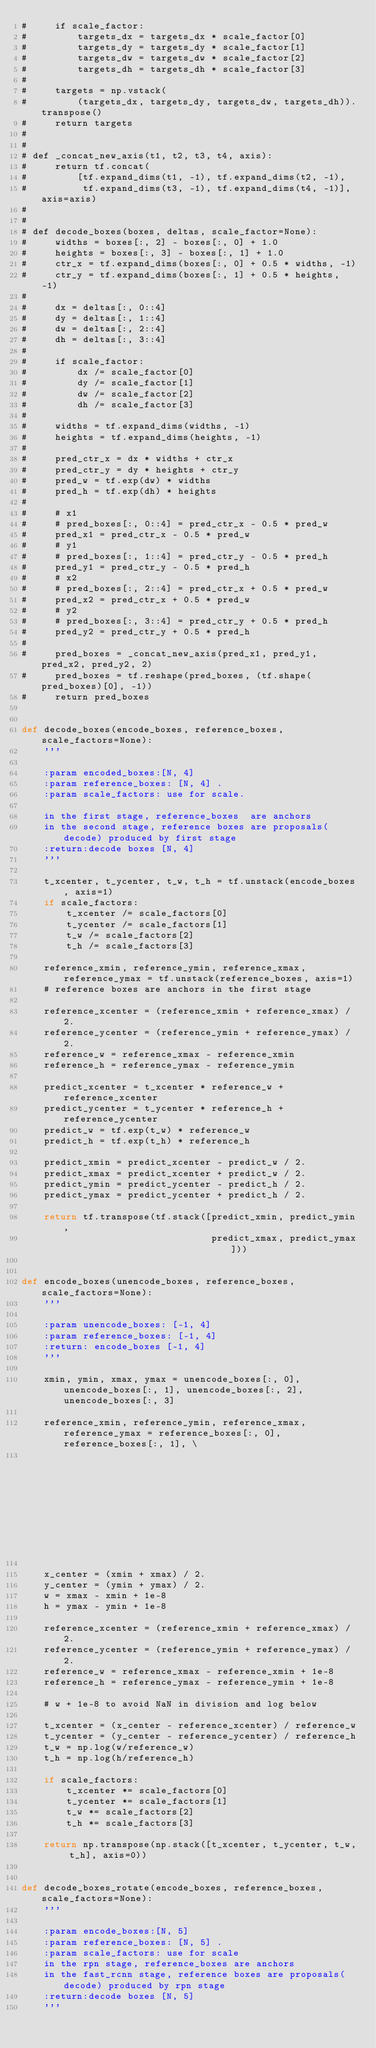Convert code to text. <code><loc_0><loc_0><loc_500><loc_500><_Python_>#     if scale_factor:
#         targets_dx = targets_dx * scale_factor[0]
#         targets_dy = targets_dy * scale_factor[1]
#         targets_dw = targets_dw * scale_factor[2]
#         targets_dh = targets_dh * scale_factor[3]
#
#     targets = np.vstack(
#         (targets_dx, targets_dy, targets_dw, targets_dh)).transpose()
#     return targets
#
#
# def _concat_new_axis(t1, t2, t3, t4, axis):
#     return tf.concat(
#         [tf.expand_dims(t1, -1), tf.expand_dims(t2, -1),
#          tf.expand_dims(t3, -1), tf.expand_dims(t4, -1)], axis=axis)
#
#
# def decode_boxes(boxes, deltas, scale_factor=None):
#     widths = boxes[:, 2] - boxes[:, 0] + 1.0
#     heights = boxes[:, 3] - boxes[:, 1] + 1.0
#     ctr_x = tf.expand_dims(boxes[:, 0] + 0.5 * widths, -1)
#     ctr_y = tf.expand_dims(boxes[:, 1] + 0.5 * heights, -1)
#
#     dx = deltas[:, 0::4]
#     dy = deltas[:, 1::4]
#     dw = deltas[:, 2::4]
#     dh = deltas[:, 3::4]
#
#     if scale_factor:
#         dx /= scale_factor[0]
#         dy /= scale_factor[1]
#         dw /= scale_factor[2]
#         dh /= scale_factor[3]
#
#     widths = tf.expand_dims(widths, -1)
#     heights = tf.expand_dims(heights, -1)
#
#     pred_ctr_x = dx * widths + ctr_x
#     pred_ctr_y = dy * heights + ctr_y
#     pred_w = tf.exp(dw) * widths
#     pred_h = tf.exp(dh) * heights
#
#     # x1
#     # pred_boxes[:, 0::4] = pred_ctr_x - 0.5 * pred_w
#     pred_x1 = pred_ctr_x - 0.5 * pred_w
#     # y1
#     # pred_boxes[:, 1::4] = pred_ctr_y - 0.5 * pred_h
#     pred_y1 = pred_ctr_y - 0.5 * pred_h
#     # x2
#     # pred_boxes[:, 2::4] = pred_ctr_x + 0.5 * pred_w
#     pred_x2 = pred_ctr_x + 0.5 * pred_w
#     # y2
#     # pred_boxes[:, 3::4] = pred_ctr_y + 0.5 * pred_h
#     pred_y2 = pred_ctr_y + 0.5 * pred_h
#
#     pred_boxes = _concat_new_axis(pred_x1, pred_y1, pred_x2, pred_y2, 2)
#     pred_boxes = tf.reshape(pred_boxes, (tf.shape(pred_boxes)[0], -1))
#     return pred_boxes


def decode_boxes(encode_boxes, reference_boxes, scale_factors=None):
    '''

    :param encoded_boxes:[N, 4]
    :param reference_boxes: [N, 4] .
    :param scale_factors: use for scale.

    in the first stage, reference_boxes  are anchors
    in the second stage, reference boxes are proposals(decode) produced by first stage
    :return:decode boxes [N, 4]
    '''

    t_xcenter, t_ycenter, t_w, t_h = tf.unstack(encode_boxes, axis=1)
    if scale_factors:
        t_xcenter /= scale_factors[0]
        t_ycenter /= scale_factors[1]
        t_w /= scale_factors[2]
        t_h /= scale_factors[3]

    reference_xmin, reference_ymin, reference_xmax, reference_ymax = tf.unstack(reference_boxes, axis=1)
    # reference boxes are anchors in the first stage

    reference_xcenter = (reference_xmin + reference_xmax) / 2.
    reference_ycenter = (reference_ymin + reference_ymax) / 2.
    reference_w = reference_xmax - reference_xmin
    reference_h = reference_ymax - reference_ymin

    predict_xcenter = t_xcenter * reference_w + reference_xcenter
    predict_ycenter = t_ycenter * reference_h + reference_ycenter
    predict_w = tf.exp(t_w) * reference_w
    predict_h = tf.exp(t_h) * reference_h

    predict_xmin = predict_xcenter - predict_w / 2.
    predict_xmax = predict_xcenter + predict_w / 2.
    predict_ymin = predict_ycenter - predict_h / 2.
    predict_ymax = predict_ycenter + predict_h / 2.

    return tf.transpose(tf.stack([predict_xmin, predict_ymin,
                                  predict_xmax, predict_ymax]))


def encode_boxes(unencode_boxes, reference_boxes, scale_factors=None):
    '''

    :param unencode_boxes: [-1, 4]
    :param reference_boxes: [-1, 4]
    :return: encode_boxes [-1, 4]
    '''

    xmin, ymin, xmax, ymax = unencode_boxes[:, 0], unencode_boxes[:, 1], unencode_boxes[:, 2], unencode_boxes[:, 3]

    reference_xmin, reference_ymin, reference_xmax, reference_ymax = reference_boxes[:, 0], reference_boxes[:, 1], \
                                                                     reference_boxes[:, 2], reference_boxes[:, 3]

    x_center = (xmin + xmax) / 2.
    y_center = (ymin + ymax) / 2.
    w = xmax - xmin + 1e-8
    h = ymax - ymin + 1e-8

    reference_xcenter = (reference_xmin + reference_xmax) / 2.
    reference_ycenter = (reference_ymin + reference_ymax) / 2.
    reference_w = reference_xmax - reference_xmin + 1e-8
    reference_h = reference_ymax - reference_ymin + 1e-8

    # w + 1e-8 to avoid NaN in division and log below

    t_xcenter = (x_center - reference_xcenter) / reference_w
    t_ycenter = (y_center - reference_ycenter) / reference_h
    t_w = np.log(w/reference_w)
    t_h = np.log(h/reference_h)

    if scale_factors:
        t_xcenter *= scale_factors[0]
        t_ycenter *= scale_factors[1]
        t_w *= scale_factors[2]
        t_h *= scale_factors[3]

    return np.transpose(np.stack([t_xcenter, t_ycenter, t_w, t_h], axis=0))


def decode_boxes_rotate(encode_boxes, reference_boxes, scale_factors=None):
    '''

    :param encode_boxes:[N, 5]
    :param reference_boxes: [N, 5] .
    :param scale_factors: use for scale
    in the rpn stage, reference_boxes are anchors
    in the fast_rcnn stage, reference boxes are proposals(decode) produced by rpn stage
    :return:decode boxes [N, 5]
    '''
</code> 